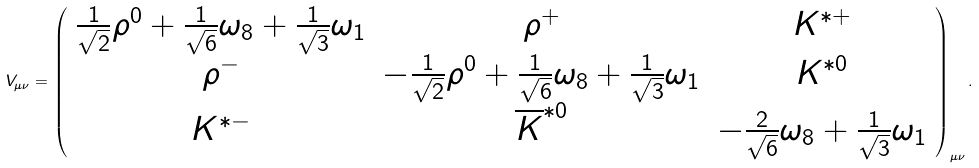<formula> <loc_0><loc_0><loc_500><loc_500>V _ { \mu \nu } = \left ( { \begin{array} { * { 3 } c } { \frac { 1 } { \sqrt { 2 } } \rho ^ { 0 } + \frac { 1 } { \sqrt { 6 } } \omega _ { 8 } + \frac { 1 } { \sqrt { 3 } } \omega _ { 1 } } & { \rho ^ { + } } & { K ^ { \ast + } } \\ { \rho ^ { - } } & { - \frac { 1 } { \sqrt { 2 } } \rho ^ { 0 } + \frac { 1 } { \sqrt { 6 } } \omega _ { 8 } + \frac { 1 } { \sqrt { 3 } } \omega _ { 1 } } & { K ^ { \ast 0 } } \\ { K ^ { \ast - } } & { \overline { K } ^ { \ast 0 } } & { - \frac { 2 } { \sqrt { 6 } } \omega _ { 8 } + \frac { 1 } { \sqrt { 3 } } \omega _ { 1 } } \\ \end{array} } \right ) _ { \mu \nu } .</formula> 